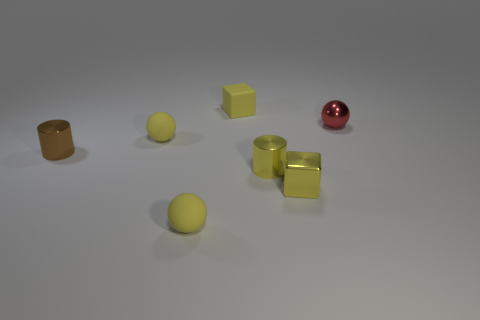Subtract all small red balls. How many balls are left? 2 Subtract 1 balls. How many balls are left? 2 Add 1 green matte spheres. How many objects exist? 8 Subtract all red balls. How many balls are left? 2 Add 5 blocks. How many blocks are left? 7 Add 2 metallic blocks. How many metallic blocks exist? 3 Subtract 0 green blocks. How many objects are left? 7 Subtract all balls. How many objects are left? 4 Subtract all brown cylinders. Subtract all cyan blocks. How many cylinders are left? 1 Subtract all red blocks. How many purple cylinders are left? 0 